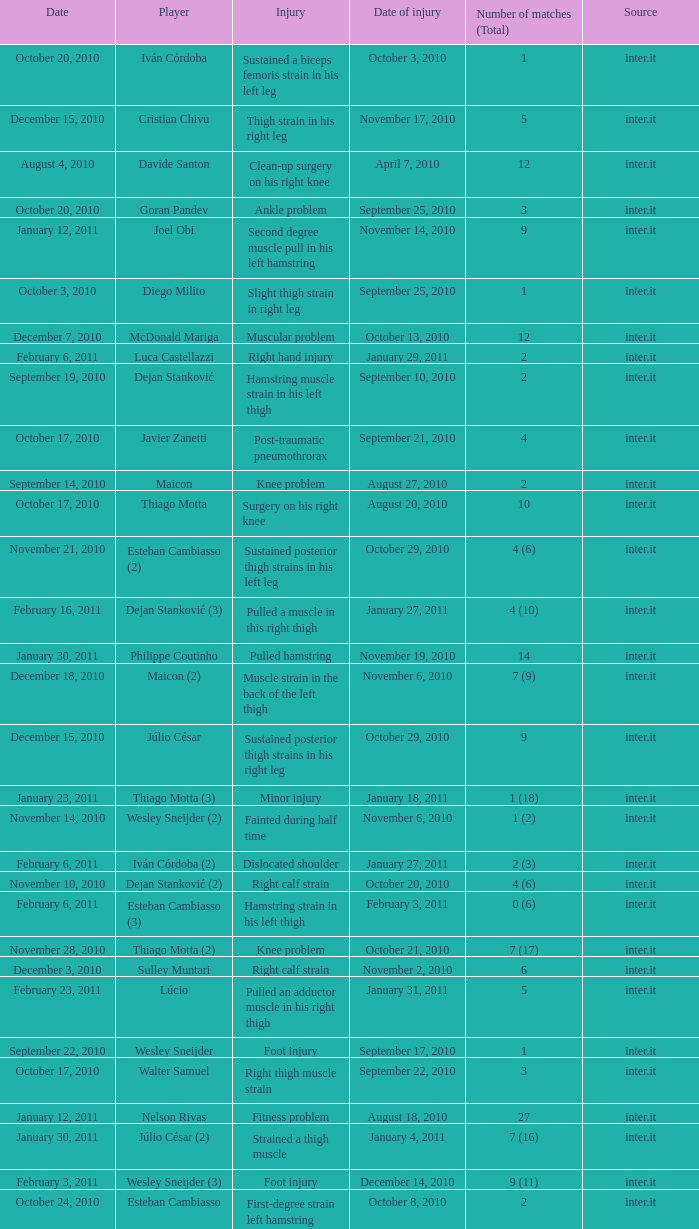Give me the full table as a dictionary. {'header': ['Date', 'Player', 'Injury', 'Date of injury', 'Number of matches (Total)', 'Source'], 'rows': [['October 20, 2010', 'Iván Córdoba', 'Sustained a biceps femoris strain in his left leg', 'October 3, 2010', '1', 'inter.it'], ['December 15, 2010', 'Cristian Chivu', 'Thigh strain in his right leg', 'November 17, 2010', '5', 'inter.it'], ['August 4, 2010', 'Davide Santon', 'Clean-up surgery on his right knee', 'April 7, 2010', '12', 'inter.it'], ['October 20, 2010', 'Goran Pandev', 'Ankle problem', 'September 25, 2010', '3', 'inter.it'], ['January 12, 2011', 'Joel Obi', 'Second degree muscle pull in his left hamstring', 'November 14, 2010', '9', 'inter.it'], ['October 3, 2010', 'Diego Milito', 'Slight thigh strain in right leg', 'September 25, 2010', '1', 'inter.it'], ['December 7, 2010', 'McDonald Mariga', 'Muscular problem', 'October 13, 2010', '12', 'inter.it'], ['February 6, 2011', 'Luca Castellazzi', 'Right hand injury', 'January 29, 2011', '2', 'inter.it'], ['September 19, 2010', 'Dejan Stanković', 'Hamstring muscle strain in his left thigh', 'September 10, 2010', '2', 'inter.it'], ['October 17, 2010', 'Javier Zanetti', 'Post-traumatic pneumothrorax', 'September 21, 2010', '4', 'inter.it'], ['September 14, 2010', 'Maicon', 'Knee problem', 'August 27, 2010', '2', 'inter.it'], ['October 17, 2010', 'Thiago Motta', 'Surgery on his right knee', 'August 20, 2010', '10', 'inter.it'], ['November 21, 2010', 'Esteban Cambiasso (2)', 'Sustained posterior thigh strains in his left leg', 'October 29, 2010', '4 (6)', 'inter.it'], ['February 16, 2011', 'Dejan Stanković (3)', 'Pulled a muscle in this right thigh', 'January 27, 2011', '4 (10)', 'inter.it'], ['January 30, 2011', 'Philippe Coutinho', 'Pulled hamstring', 'November 19, 2010', '14', 'inter.it'], ['December 18, 2010', 'Maicon (2)', 'Muscle strain in the back of the left thigh', 'November 6, 2010', '7 (9)', 'inter.it'], ['December 15, 2010', 'Júlio César', 'Sustained posterior thigh strains in his right leg', 'October 29, 2010', '9', 'inter.it'], ['January 23, 2011', 'Thiago Motta (3)', 'Minor injury', 'January 18, 2011', '1 (18)', 'inter.it'], ['November 14, 2010', 'Wesley Sneijder (2)', 'Fainted during half time', 'November 6, 2010', '1 (2)', 'inter.it'], ['February 6, 2011', 'Iván Córdoba (2)', 'Dislocated shoulder', 'January 27, 2011', '2 (3)', 'inter.it'], ['November 10, 2010', 'Dejan Stanković (2)', 'Right calf strain', 'October 20, 2010', '4 (6)', 'inter.it'], ['February 6, 2011', 'Esteban Cambiasso (3)', 'Hamstring strain in his left thigh', 'February 3, 2011', '0 (6)', 'inter.it'], ['November 28, 2010', 'Thiago Motta (2)', 'Knee problem', 'October 21, 2010', '7 (17)', 'inter.it'], ['December 3, 2010', 'Sulley Muntari', 'Right calf strain', 'November 2, 2010', '6', 'inter.it'], ['February 23, 2011', 'Lúcio', 'Pulled an adductor muscle in his right thigh', 'January 31, 2011', '5', 'inter.it'], ['September 22, 2010', 'Wesley Sneijder', 'Foot injury', 'September 17, 2010', '1', 'inter.it'], ['October 17, 2010', 'Walter Samuel', 'Right thigh muscle strain', 'September 22, 2010', '3', 'inter.it'], ['January 12, 2011', 'Nelson Rivas', 'Fitness problem', 'August 18, 2010', '27', 'inter.it'], ['January 30, 2011', 'Júlio César (2)', 'Strained a thigh muscle', 'January 4, 2011', '7 (16)', 'inter.it'], ['February 3, 2011', 'Wesley Sneijder (3)', 'Foot injury', 'December 14, 2010', '9 (11)', 'inter.it'], ['October 24, 2010', 'Esteban Cambiasso', 'First-degree strain left hamstring muscles', 'October 8, 2010', '2', 'inter.it']]} How many times was the date october 3, 2010? 1.0. 